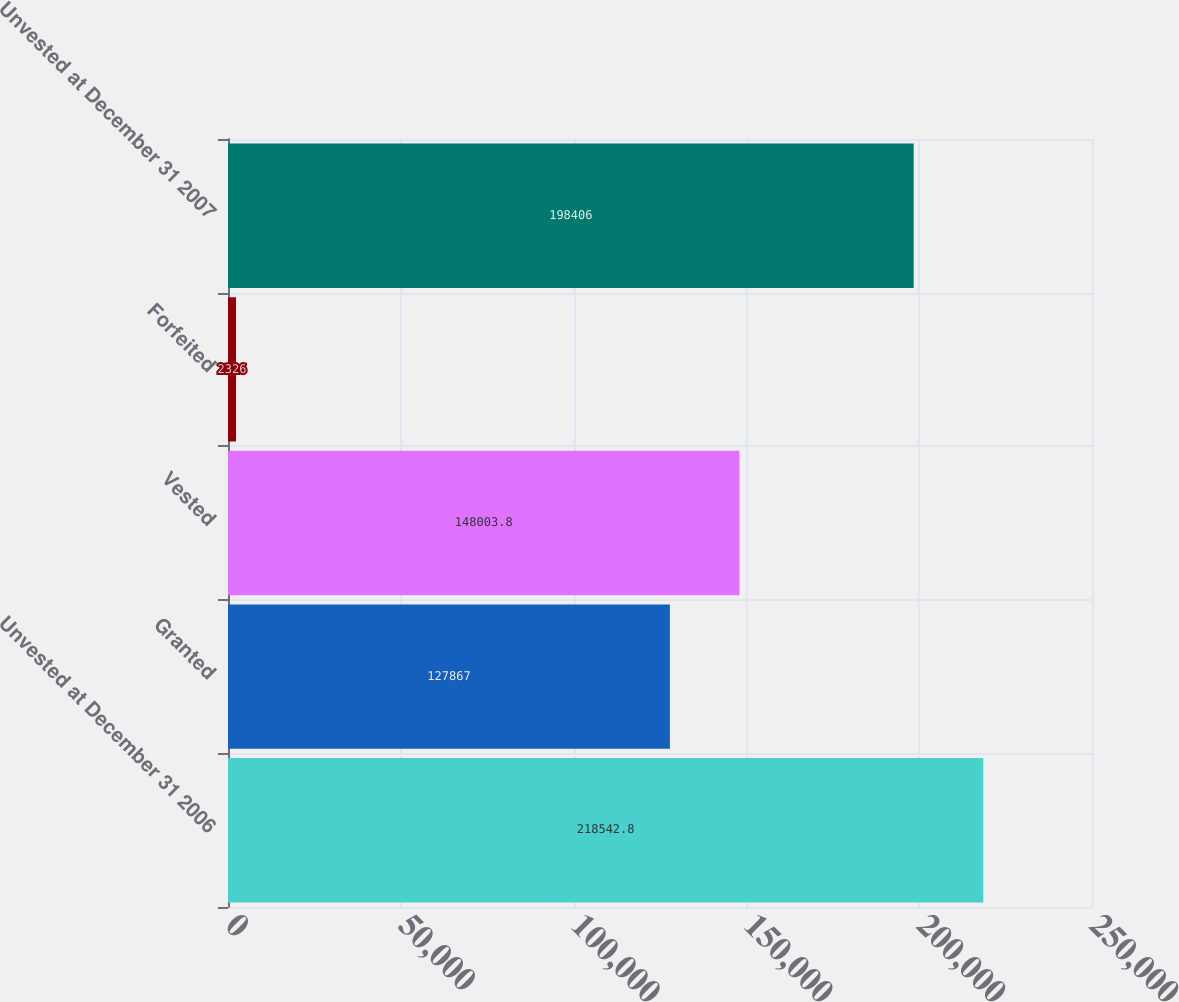Convert chart. <chart><loc_0><loc_0><loc_500><loc_500><bar_chart><fcel>Unvested at December 31 2006<fcel>Granted<fcel>Vested<fcel>Forfeited<fcel>Unvested at December 31 2007<nl><fcel>218543<fcel>127867<fcel>148004<fcel>2326<fcel>198406<nl></chart> 